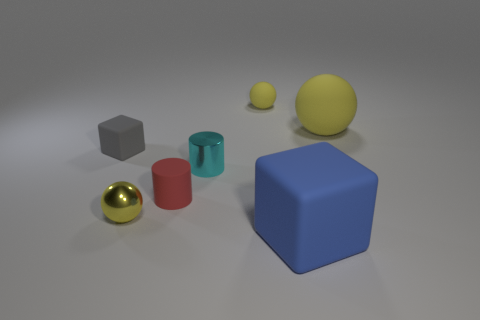Add 1 large cyan blocks. How many objects exist? 8 Subtract all spheres. How many objects are left? 4 Add 7 small red rubber cylinders. How many small red rubber cylinders are left? 8 Add 7 small cyan spheres. How many small cyan spheres exist? 7 Subtract 0 purple cylinders. How many objects are left? 7 Subtract all shiny objects. Subtract all small metallic objects. How many objects are left? 3 